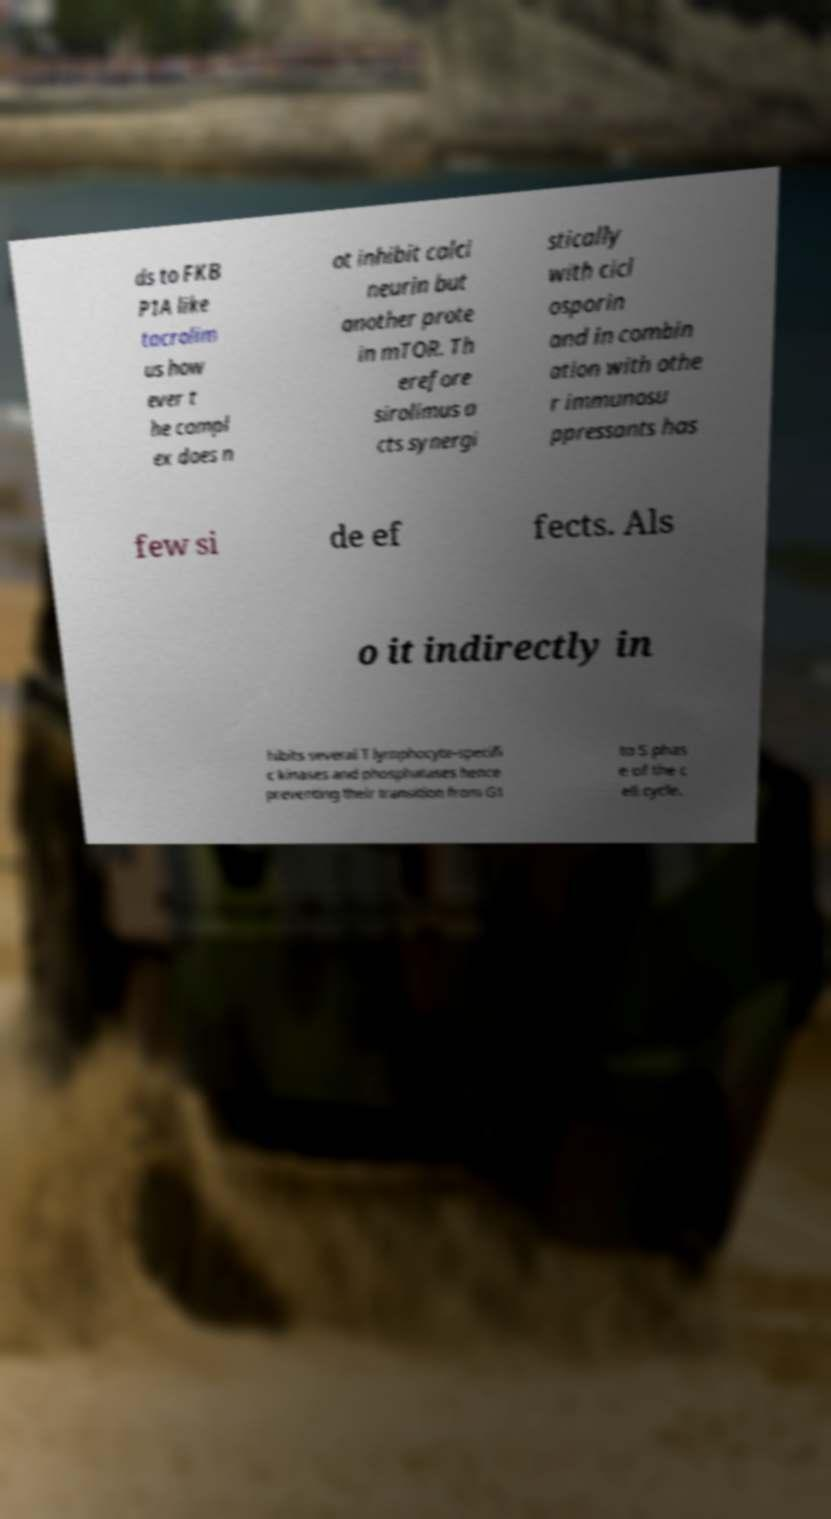I need the written content from this picture converted into text. Can you do that? ds to FKB P1A like tacrolim us how ever t he compl ex does n ot inhibit calci neurin but another prote in mTOR. Th erefore sirolimus a cts synergi stically with cicl osporin and in combin ation with othe r immunosu ppressants has few si de ef fects. Als o it indirectly in hibits several T lymphocyte-specifi c kinases and phosphatases hence preventing their transition from G1 to S phas e of the c ell cycle. 